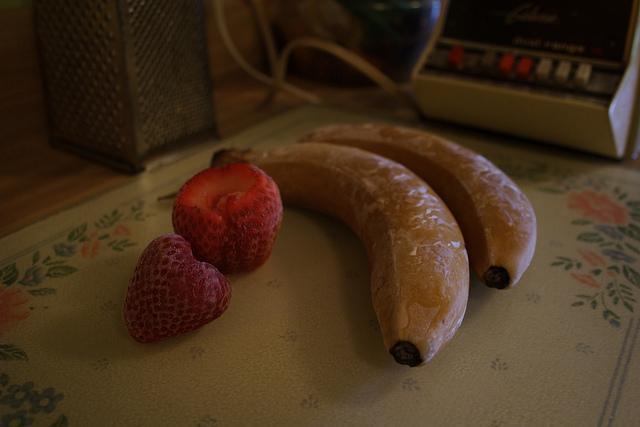How many bananas are in the picture?
Give a very brief answer. 2. 